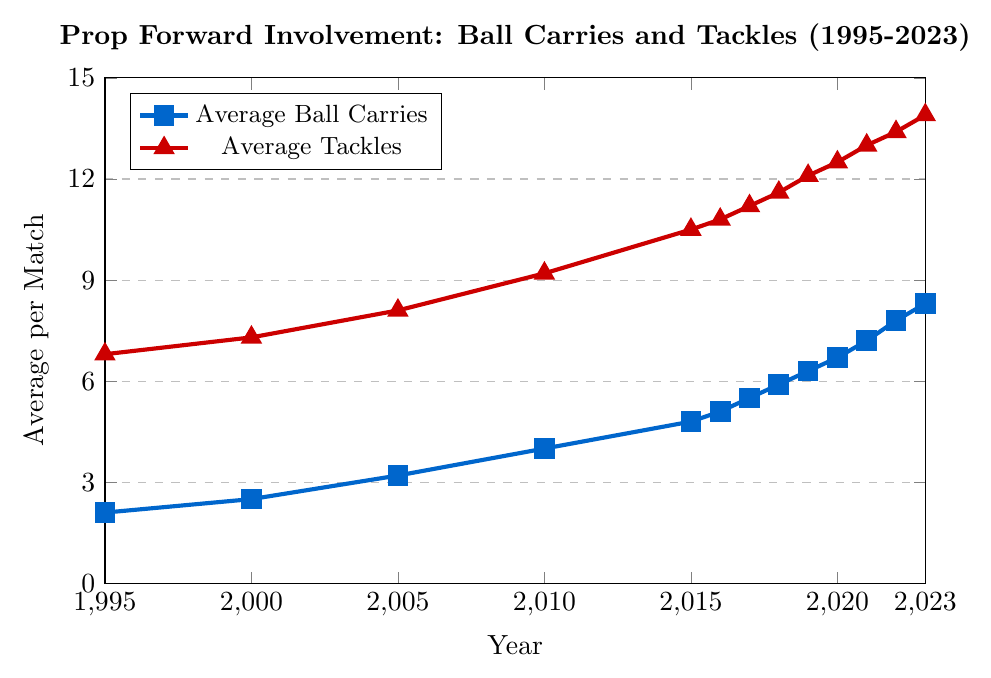Which year had the lowest average ball carries by prop forwards? The figure shows the evolution of average ball carries from 1995 to 2023. The lowest value appears at the beginning of the timeline.
Answer: 1995 How much did the average tackles increase from 2005 to 2023? The average tackles in 2005 were 8.1 and in 2023 they were 13.9. The increase is calculated as 13.9 - 8.1.
Answer: 5.8 Compare the trends in average ball carries and tacklers. Which metric has seen a more significant increase from 1995 to 2023? The average ball carries in 1995 were 2.1 and in 2023 they were 8.3, an increase of 6.2. The average tackles in 1995 were 6.8 and in 2023 they were 13.9, an increase of 7.1. The average tackles have seen a more significant increase.
Answer: Average tackles Between which consecutive years did the average ball carries have the highest increase? By visually examining the plot, the largest jump in ball carries appears between 2014 and 2015. In 2014, the average ball carries were 4.0 and in 2015, they were 4.8.
Answer: 2010 to 2015 In which year did the average tackles reach double digits for the first time? The figure indicates how the average tackles evolved, and it first goes into double digits (10 or more) in 2010.
Answer: 2015 What is the approximate average ball carries and average tackles in the year 2018? The figure shows that in 2018, the average ball carries are around 5.9 and the average tackles are about 11.6.
Answer: Average ball carries: 5.9, Average tackles: 11.6 Which year shows the highest average ball carries by prop forwards? By checking the highest point for average ball carries, it appears in the last year shown on the plot, which is 2023.
Answer: 2023 What is the average increase in ball carries per year from 2000 to 2023? The ball carries in 2000 were 2.5 and in 2023 they were 8.3, an increase of (8.3 - 2.5) over 23 years. The average increase per year is therefore (8.3 - 2.5) / 23.
Answer: 0.25 per year 